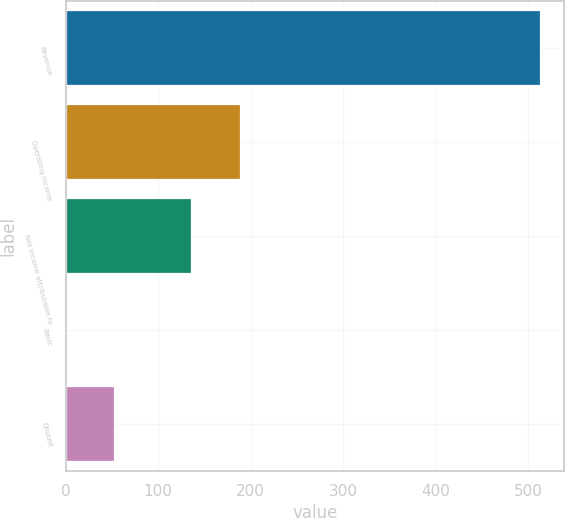Convert chart. <chart><loc_0><loc_0><loc_500><loc_500><bar_chart><fcel>Revenue<fcel>Operating income<fcel>Net income attributable to<fcel>Basic<fcel>Diluted<nl><fcel>513.3<fcel>188.9<fcel>136<fcel>0.58<fcel>51.85<nl></chart> 